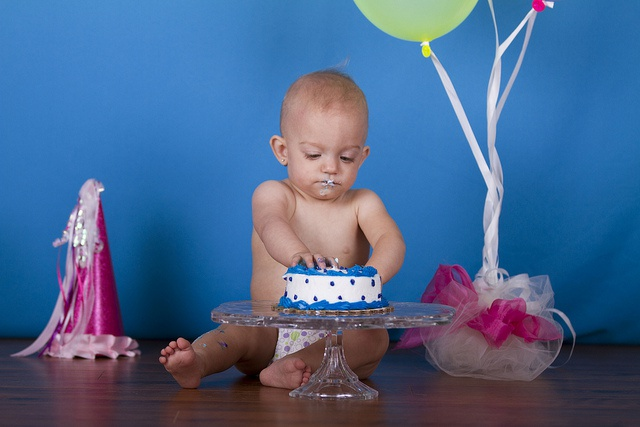Describe the objects in this image and their specific colors. I can see people in gray, lightpink, darkgray, and maroon tones and cake in gray, lightgray, blue, and darkgray tones in this image. 